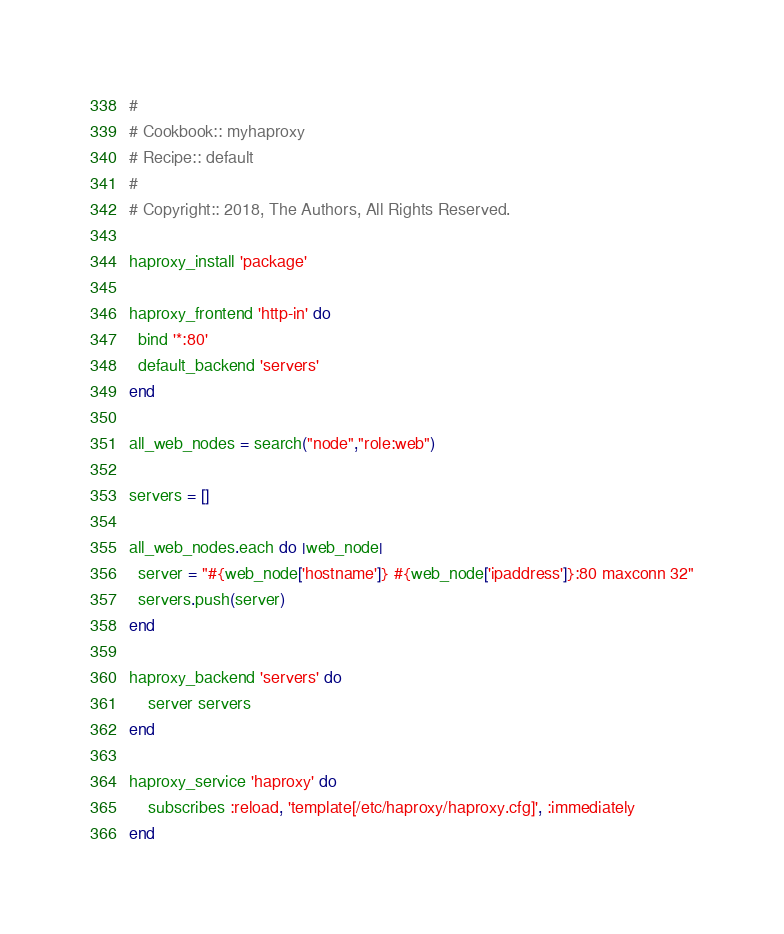Convert code to text. <code><loc_0><loc_0><loc_500><loc_500><_Ruby_>#
# Cookbook:: myhaproxy
# Recipe:: default
#
# Copyright:: 2018, The Authors, All Rights Reserved.

haproxy_install 'package'

haproxy_frontend 'http-in' do
  bind '*:80'
  default_backend 'servers'
end

all_web_nodes = search("node","role:web")

servers = []

all_web_nodes.each do |web_node|
  server = "#{web_node['hostname']} #{web_node['ipaddress']}:80 maxconn 32"
  servers.push(server)
end

haproxy_backend 'servers' do
	server servers
end

haproxy_service 'haproxy' do
	subscribes :reload, 'template[/etc/haproxy/haproxy.cfg]', :immediately
end</code> 